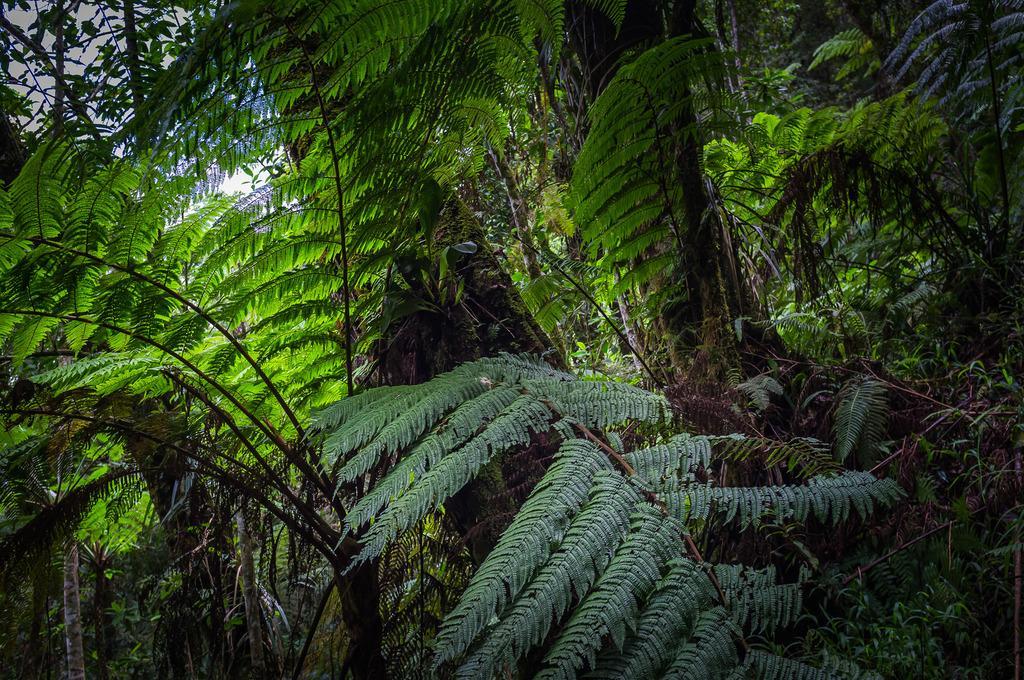How would you summarize this image in a sentence or two? In this picture there are trees. At the top there is sky and there are clouds. 